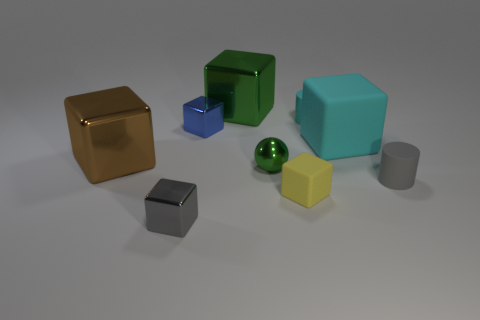Subtract all blue blocks. How many blocks are left? 5 Subtract all matte cubes. How many cubes are left? 4 Subtract all purple cubes. Subtract all cyan cylinders. How many cubes are left? 6 Add 1 small cyan cylinders. How many objects exist? 10 Subtract all cylinders. How many objects are left? 7 Add 6 large green metal objects. How many large green metal objects are left? 7 Add 7 gray metallic objects. How many gray metallic objects exist? 8 Subtract 0 purple spheres. How many objects are left? 9 Subtract all small cyan rubber things. Subtract all tiny cyan rubber cylinders. How many objects are left? 7 